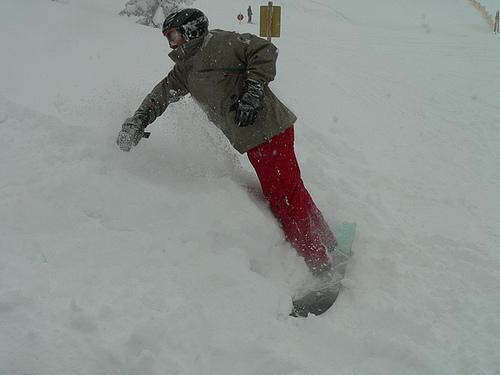Why is the person wearing a heavy jacket? cold 